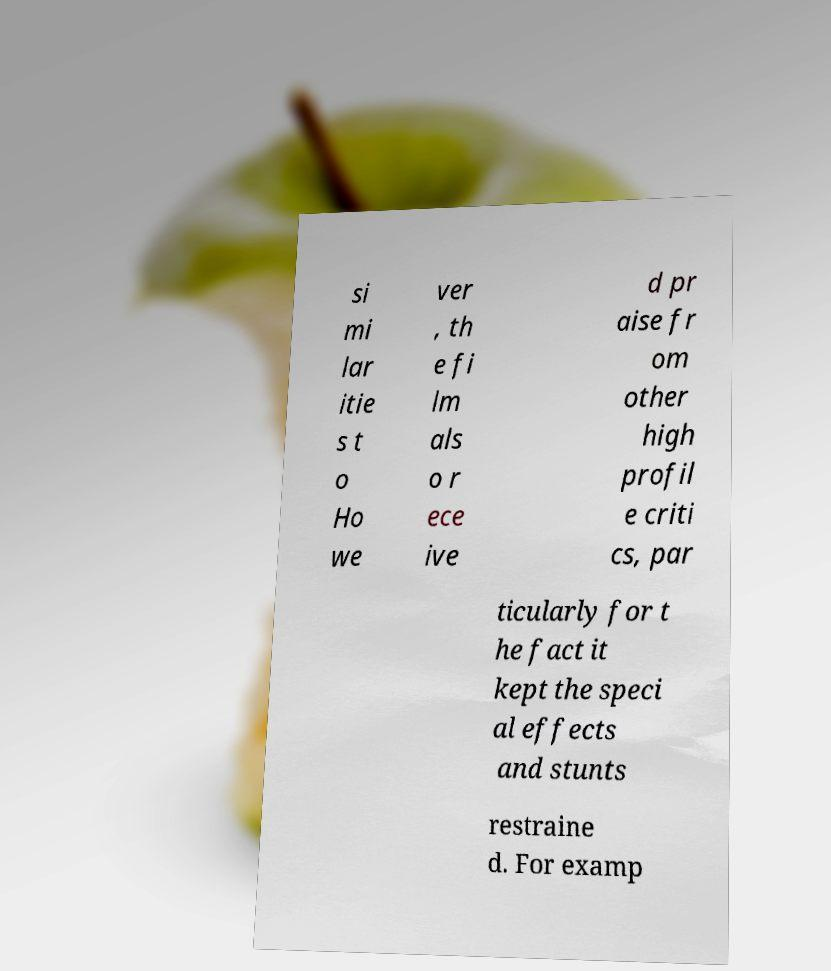Please read and relay the text visible in this image. What does it say? si mi lar itie s t o Ho we ver , th e fi lm als o r ece ive d pr aise fr om other high profil e criti cs, par ticularly for t he fact it kept the speci al effects and stunts restraine d. For examp 